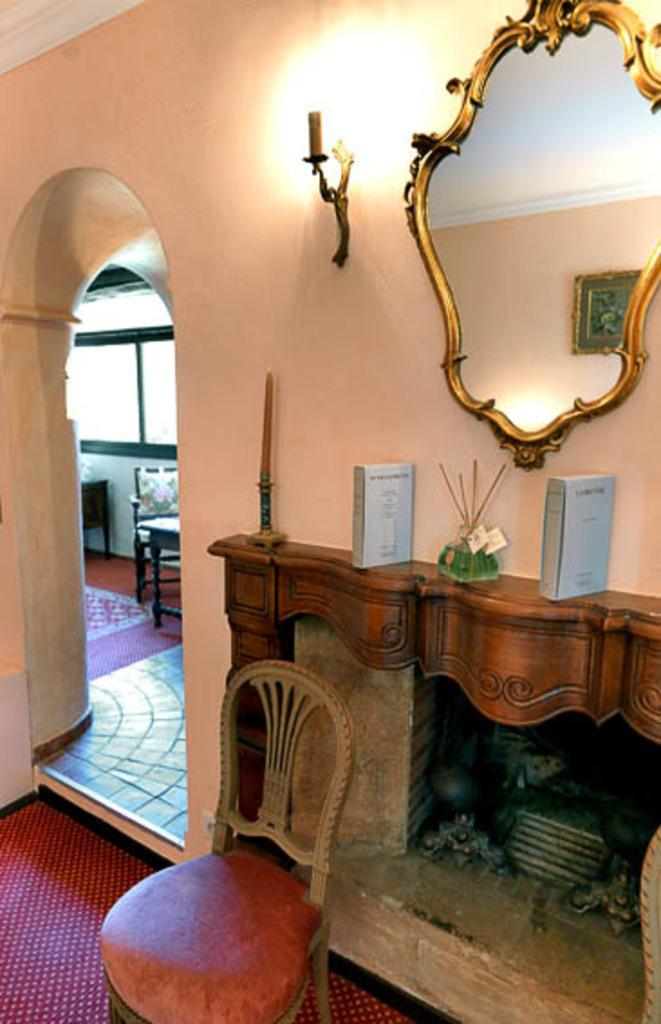What type of furniture is present in the image? There are chairs in the image. What feature can be seen in the room in the image? There is a fireplace in the image. What object is used for reflection in the image? There is a mirror in the image. What source of light is visible in the image? There is a light in the image. What type of illumination source is present in the image? There is a candle in the image. What color can be observed in the image? There are grey-colored things in the image. What type of apparatus is used for waste disposal in the image? There is no apparatus for waste disposal present in the image. What type of cart is visible in the image? There is no cart present in the image. 